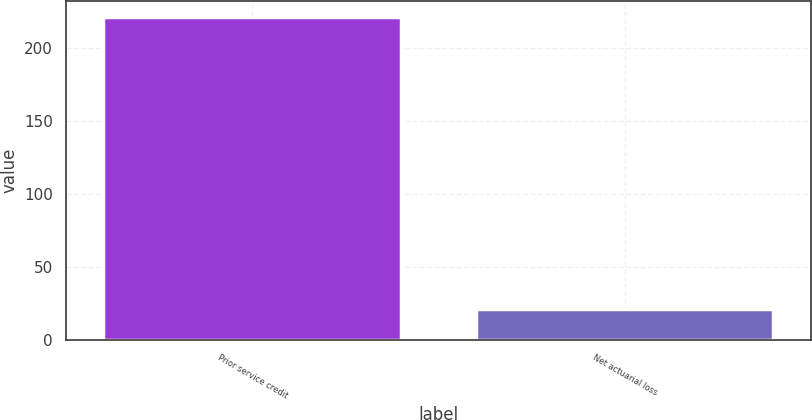Convert chart to OTSL. <chart><loc_0><loc_0><loc_500><loc_500><bar_chart><fcel>Prior service credit<fcel>Net actuarial loss<nl><fcel>221<fcel>21<nl></chart> 